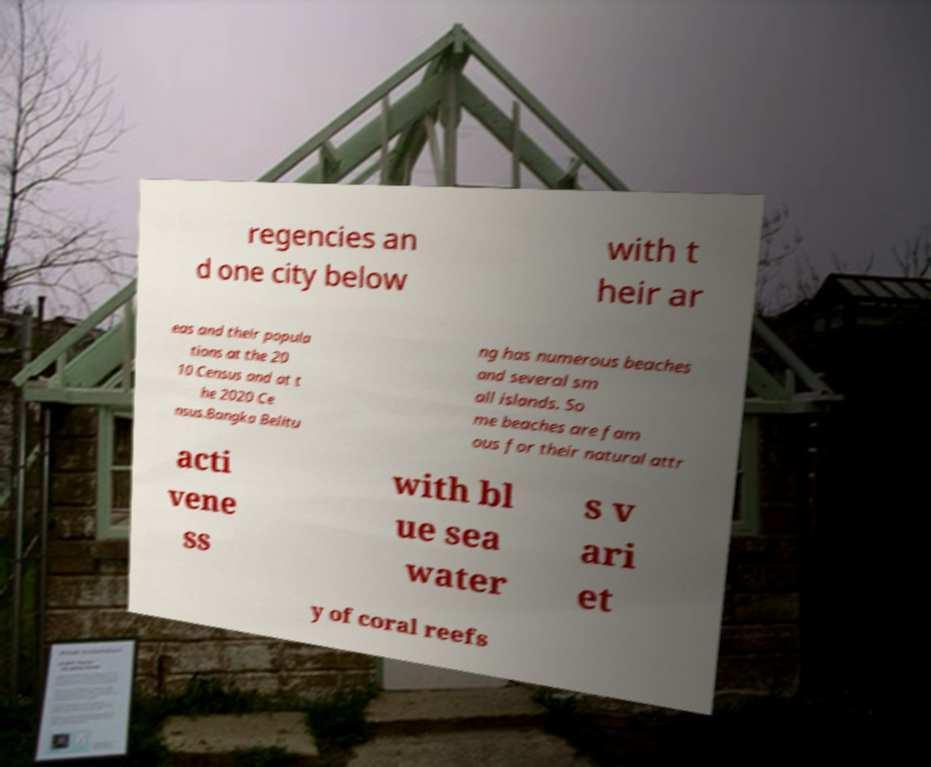Can you read and provide the text displayed in the image?This photo seems to have some interesting text. Can you extract and type it out for me? regencies an d one city below with t heir ar eas and their popula tions at the 20 10 Census and at t he 2020 Ce nsus.Bangka Belitu ng has numerous beaches and several sm all islands. So me beaches are fam ous for their natural attr acti vene ss with bl ue sea water s v ari et y of coral reefs 